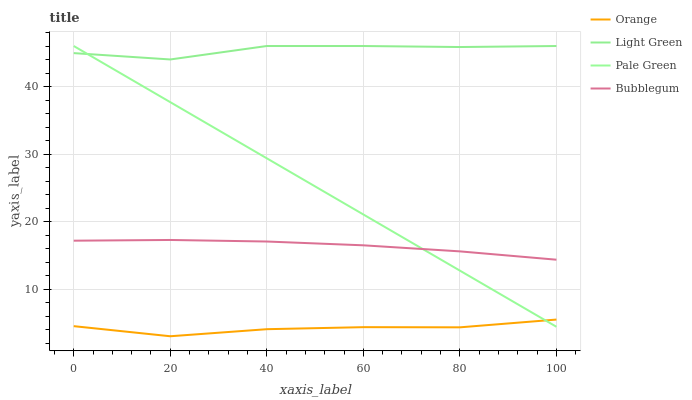Does Orange have the minimum area under the curve?
Answer yes or no. Yes. Does Light Green have the maximum area under the curve?
Answer yes or no. Yes. Does Pale Green have the minimum area under the curve?
Answer yes or no. No. Does Pale Green have the maximum area under the curve?
Answer yes or no. No. Is Pale Green the smoothest?
Answer yes or no. Yes. Is Light Green the roughest?
Answer yes or no. Yes. Is Bubblegum the smoothest?
Answer yes or no. No. Is Bubblegum the roughest?
Answer yes or no. No. Does Orange have the lowest value?
Answer yes or no. Yes. Does Pale Green have the lowest value?
Answer yes or no. No. Does Light Green have the highest value?
Answer yes or no. Yes. Does Bubblegum have the highest value?
Answer yes or no. No. Is Orange less than Light Green?
Answer yes or no. Yes. Is Light Green greater than Orange?
Answer yes or no. Yes. Does Orange intersect Pale Green?
Answer yes or no. Yes. Is Orange less than Pale Green?
Answer yes or no. No. Is Orange greater than Pale Green?
Answer yes or no. No. Does Orange intersect Light Green?
Answer yes or no. No. 